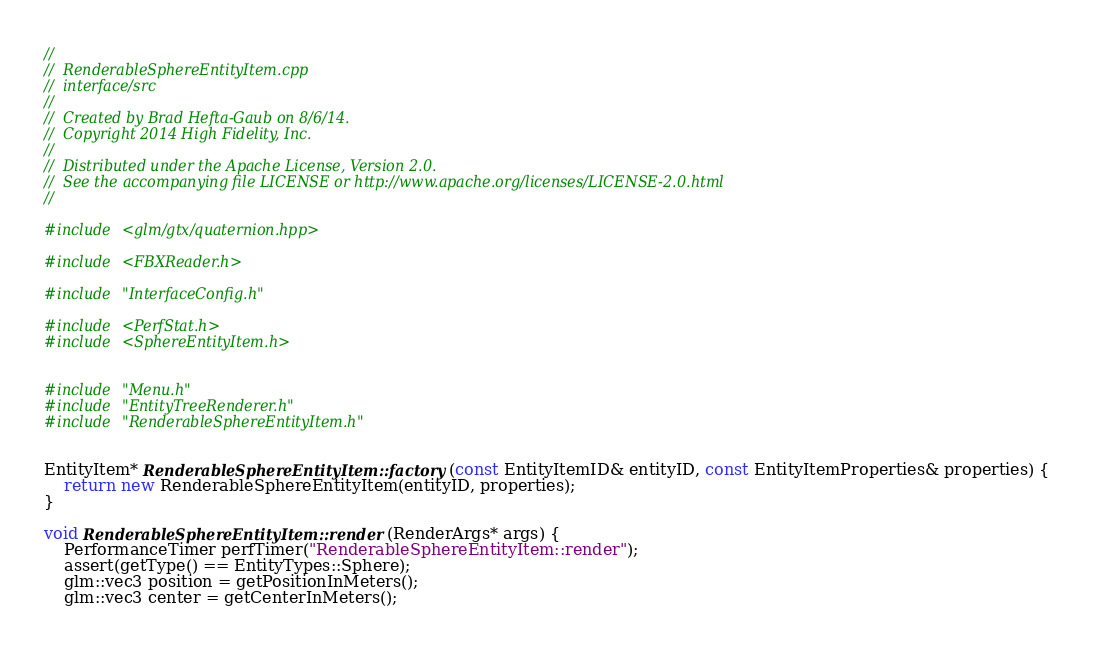Convert code to text. <code><loc_0><loc_0><loc_500><loc_500><_C++_>//
//  RenderableSphereEntityItem.cpp
//  interface/src
//
//  Created by Brad Hefta-Gaub on 8/6/14.
//  Copyright 2014 High Fidelity, Inc.
//
//  Distributed under the Apache License, Version 2.0.
//  See the accompanying file LICENSE or http://www.apache.org/licenses/LICENSE-2.0.html
//

#include <glm/gtx/quaternion.hpp>

#include <FBXReader.h>

#include "InterfaceConfig.h"

#include <PerfStat.h>
#include <SphereEntityItem.h>


#include "Menu.h"
#include "EntityTreeRenderer.h"
#include "RenderableSphereEntityItem.h"


EntityItem* RenderableSphereEntityItem::factory(const EntityItemID& entityID, const EntityItemProperties& properties) {
    return new RenderableSphereEntityItem(entityID, properties);
}

void RenderableSphereEntityItem::render(RenderArgs* args) {
    PerformanceTimer perfTimer("RenderableSphereEntityItem::render");
    assert(getType() == EntityTypes::Sphere);
    glm::vec3 position = getPositionInMeters();
    glm::vec3 center = getCenterInMeters();</code> 